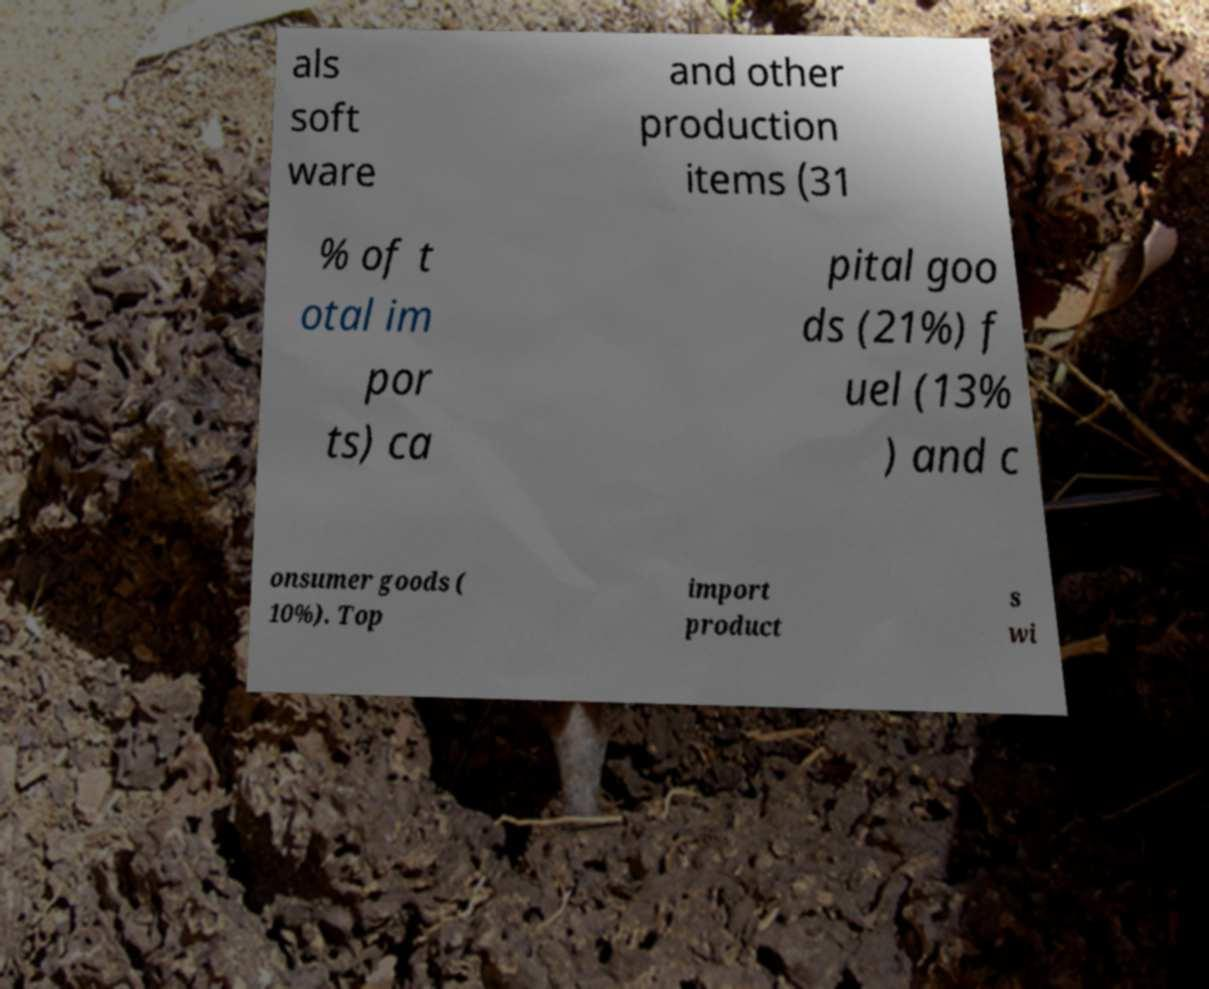Please identify and transcribe the text found in this image. als soft ware and other production items (31 % of t otal im por ts) ca pital goo ds (21%) f uel (13% ) and c onsumer goods ( 10%). Top import product s wi 